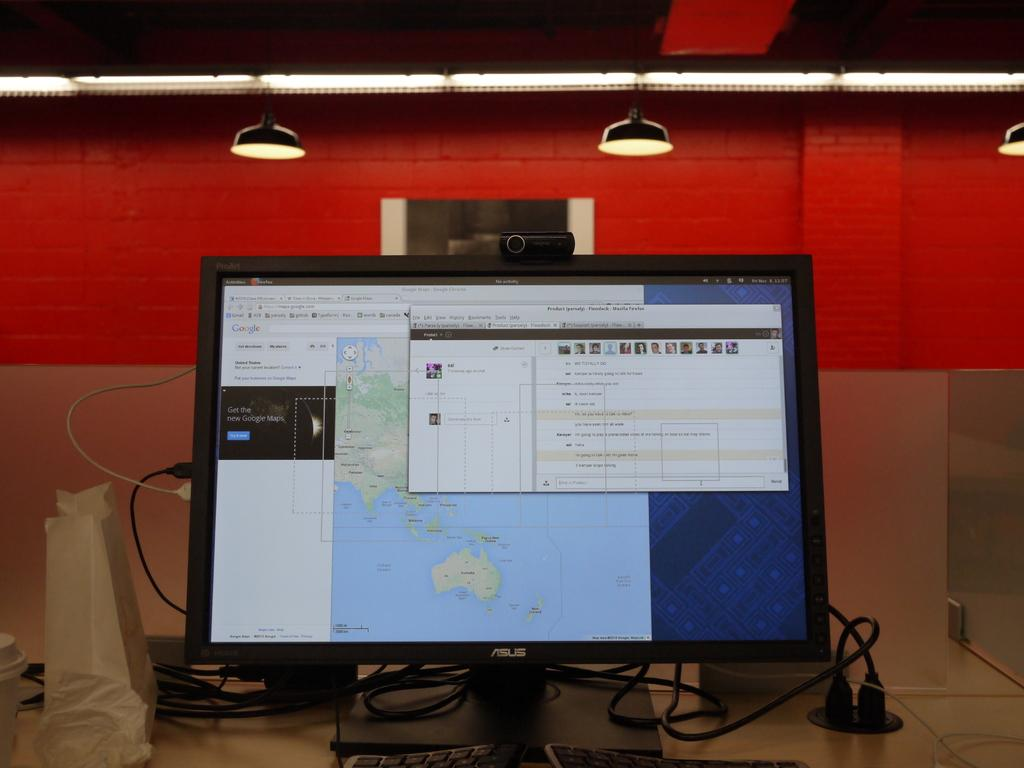Provide a one-sentence caption for the provided image. An Asus computer monitor with Google Maps and a flow chart on the screen. 